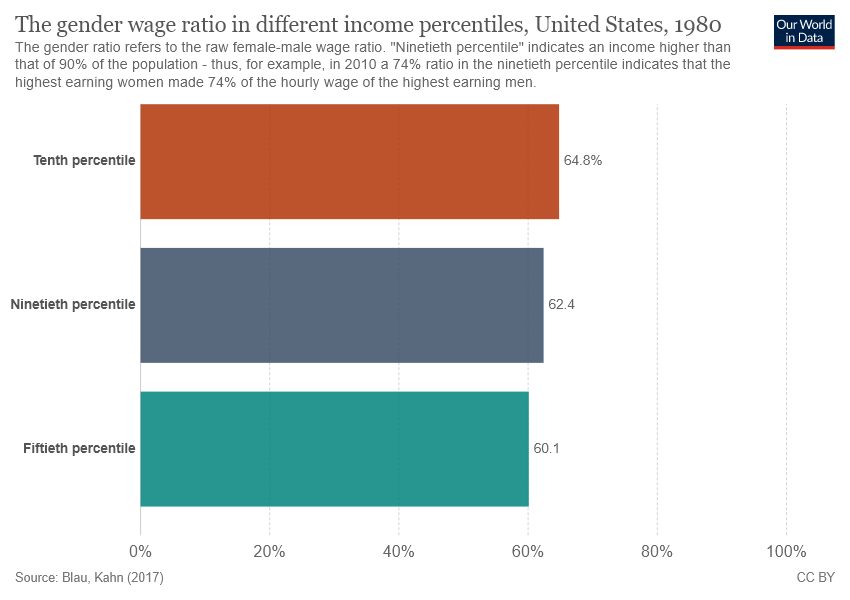Identify some key points in this picture. The top bar is valued at 64.8%. If we add the top and bottom bars and then deduct the middle bar from the result, what will the final result be? 